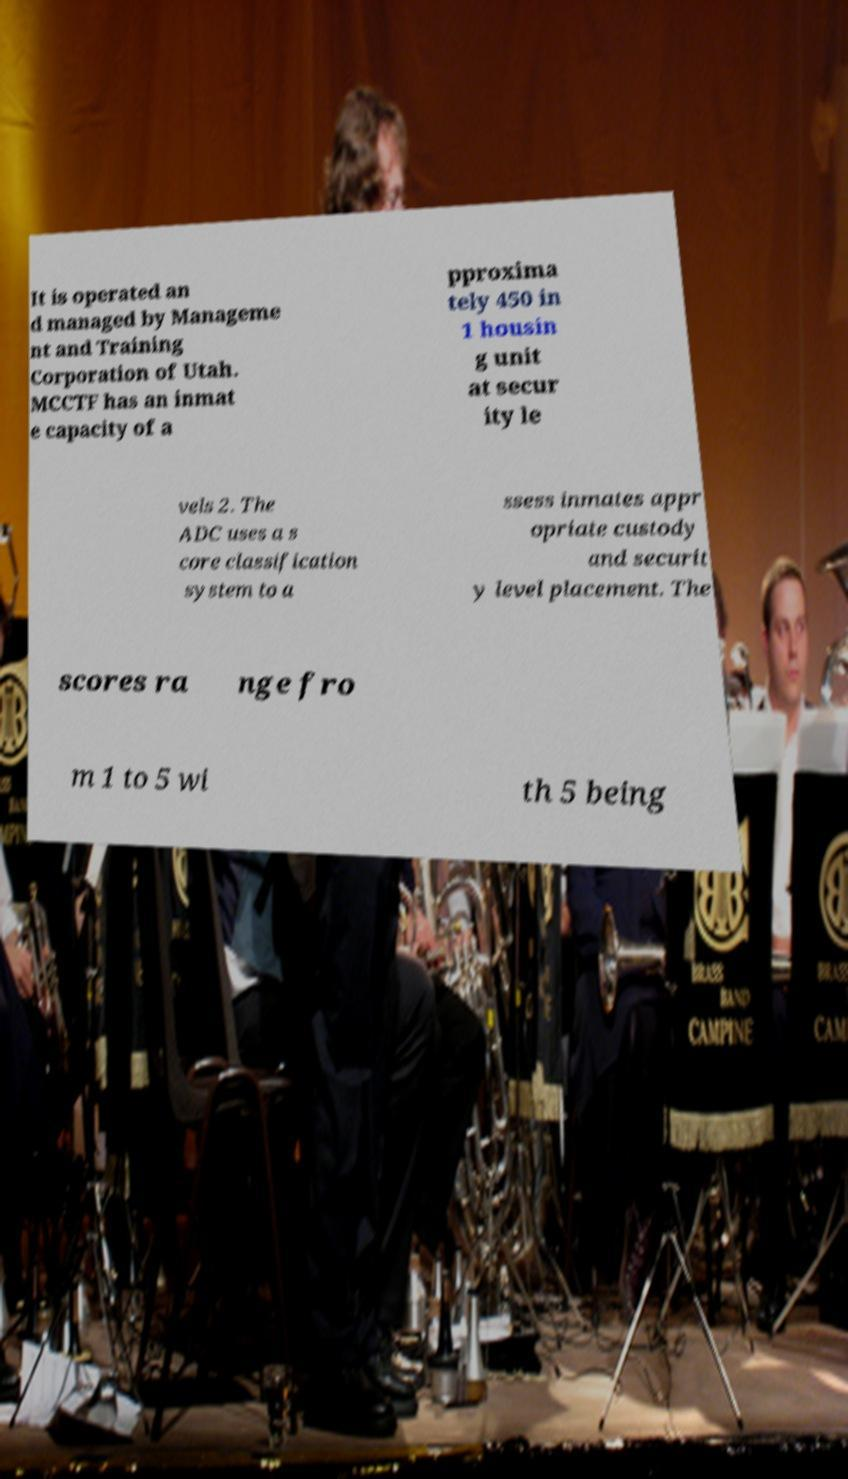Could you assist in decoding the text presented in this image and type it out clearly? It is operated an d managed by Manageme nt and Training Corporation of Utah. MCCTF has an inmat e capacity of a pproxima tely 450 in 1 housin g unit at secur ity le vels 2. The ADC uses a s core classification system to a ssess inmates appr opriate custody and securit y level placement. The scores ra nge fro m 1 to 5 wi th 5 being 